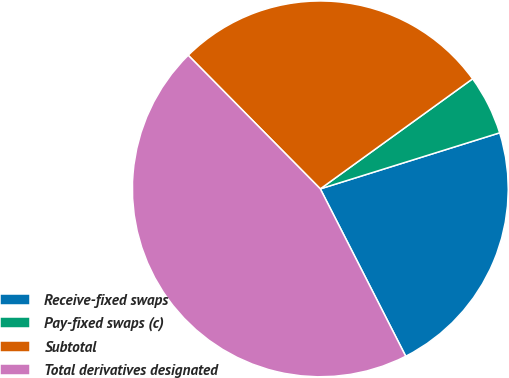Convert chart. <chart><loc_0><loc_0><loc_500><loc_500><pie_chart><fcel>Receive-fixed swaps<fcel>Pay-fixed swaps (c)<fcel>Subtotal<fcel>Total derivatives designated<nl><fcel>22.31%<fcel>5.14%<fcel>27.45%<fcel>45.1%<nl></chart> 